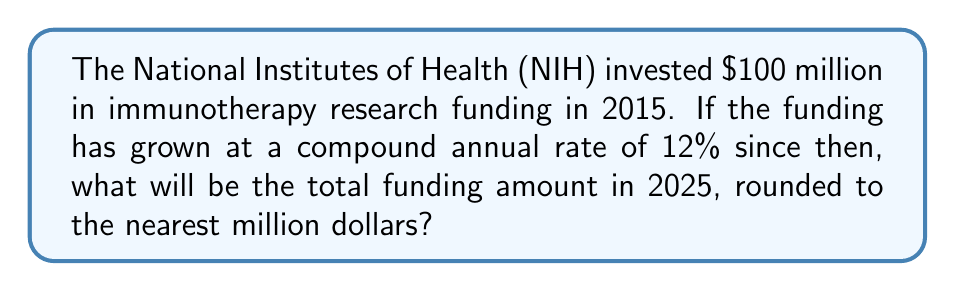Can you answer this question? Let's approach this step-by-step:

1) We're dealing with compound growth, so we'll use the compound interest formula:
   $A = P(1 + r)^n$
   Where:
   $A$ = Final amount
   $P$ = Principal (initial investment)
   $r$ = Annual interest rate (in decimal form)
   $n$ = Number of years

2) We know:
   $P = $100$ million
   $r = 12\% = 0.12$
   $n = 2025 - 2015 = 10$ years

3) Let's plug these values into our formula:
   $A = 100(1 + 0.12)^{10}$

4) Now, let's calculate:
   $A = 100 * (1.12)^{10}$
   $A = 100 * 3.1058$
   $A = 310.58$ million

5) Rounding to the nearest million:
   $A \approx 311$ million
Answer: $311 million 